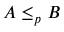<formula> <loc_0><loc_0><loc_500><loc_500>A \leq _ { p } B</formula> 